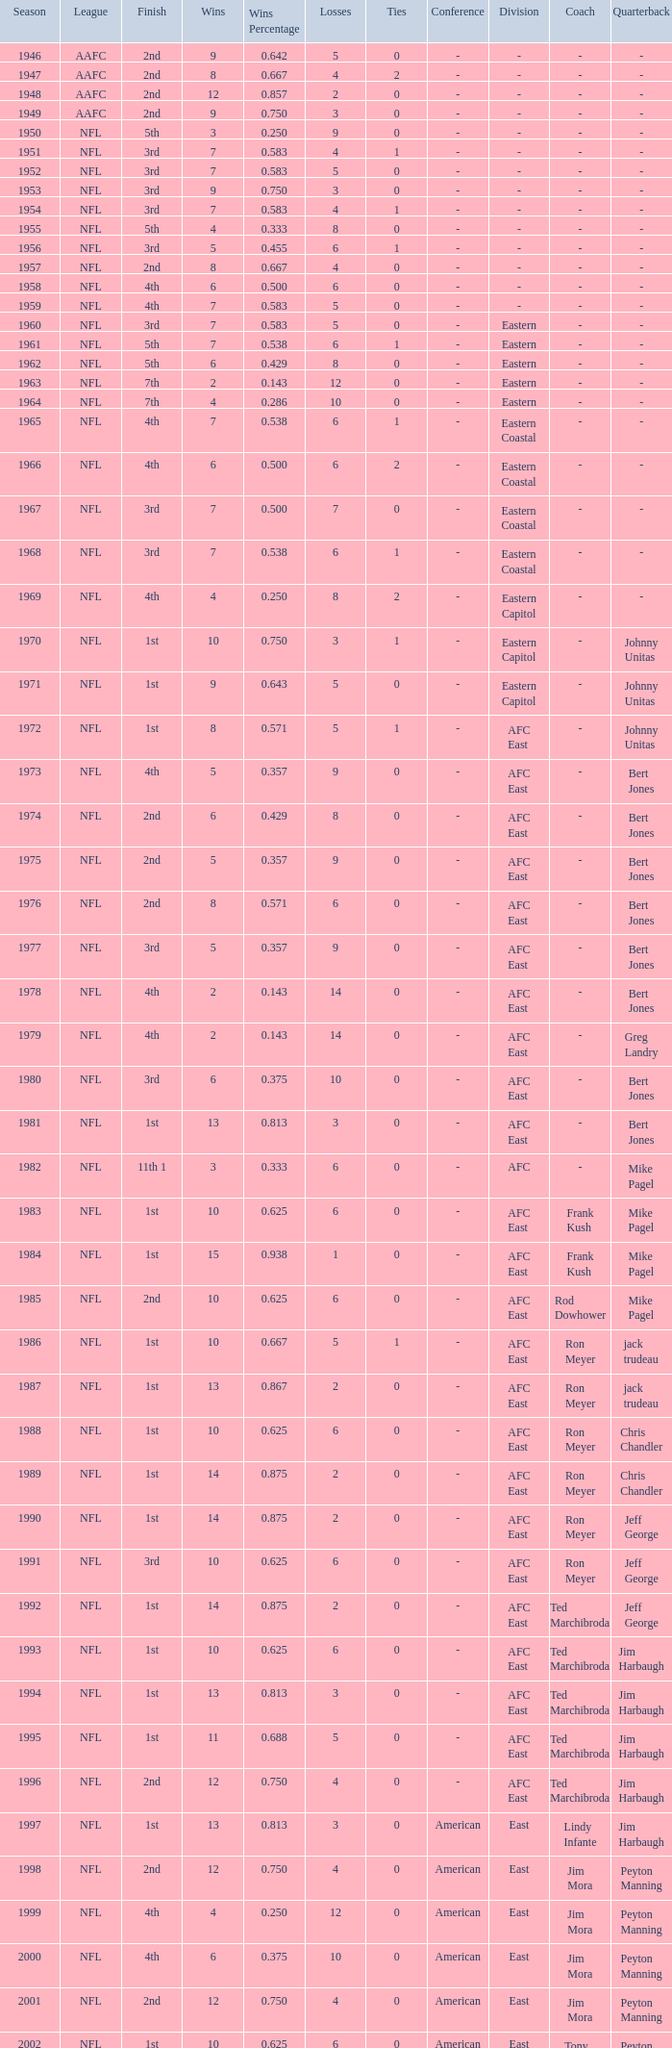What is the losses in the NFL in the 2011 season with less than 13 wins? None. 